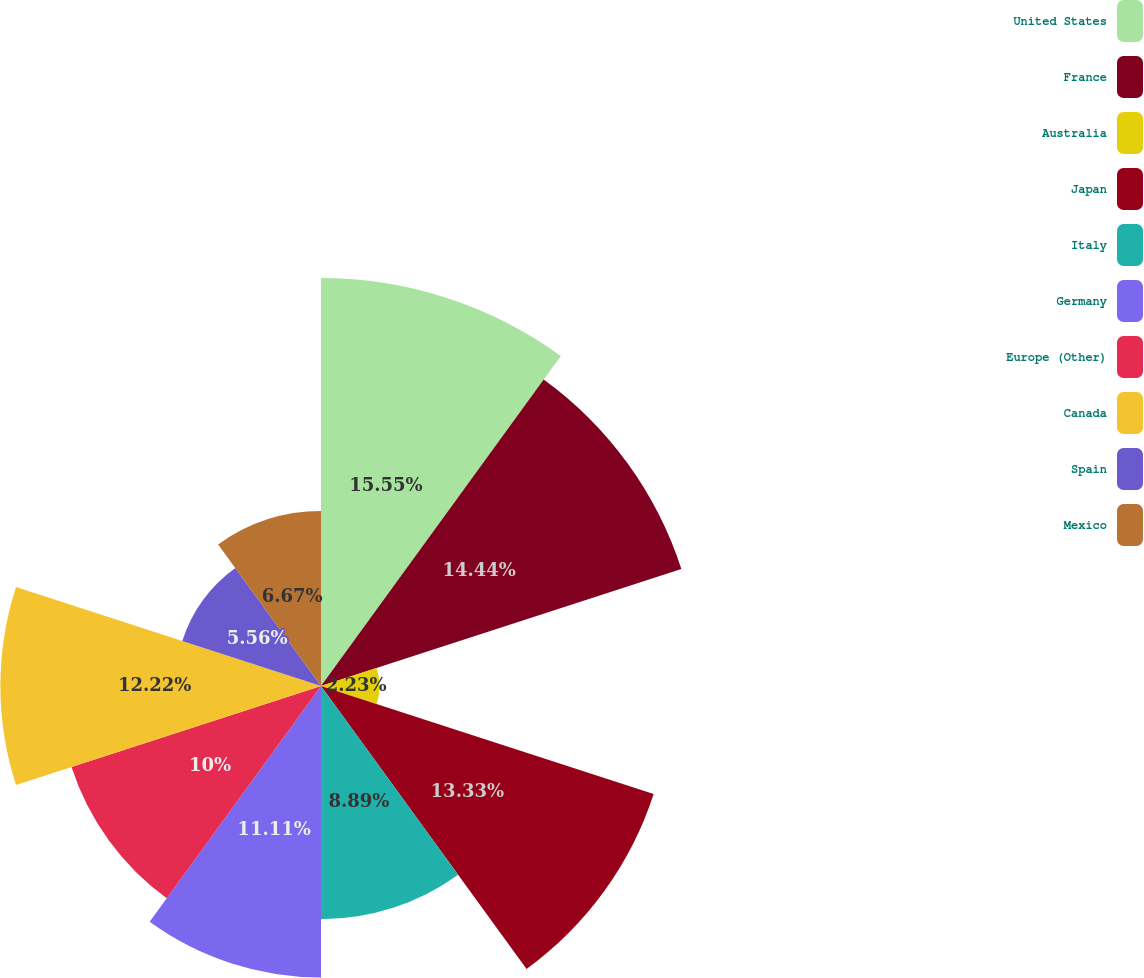Convert chart. <chart><loc_0><loc_0><loc_500><loc_500><pie_chart><fcel>United States<fcel>France<fcel>Australia<fcel>Japan<fcel>Italy<fcel>Germany<fcel>Europe (Other)<fcel>Canada<fcel>Spain<fcel>Mexico<nl><fcel>15.55%<fcel>14.44%<fcel>2.23%<fcel>13.33%<fcel>8.89%<fcel>11.11%<fcel>10.0%<fcel>12.22%<fcel>5.56%<fcel>6.67%<nl></chart> 